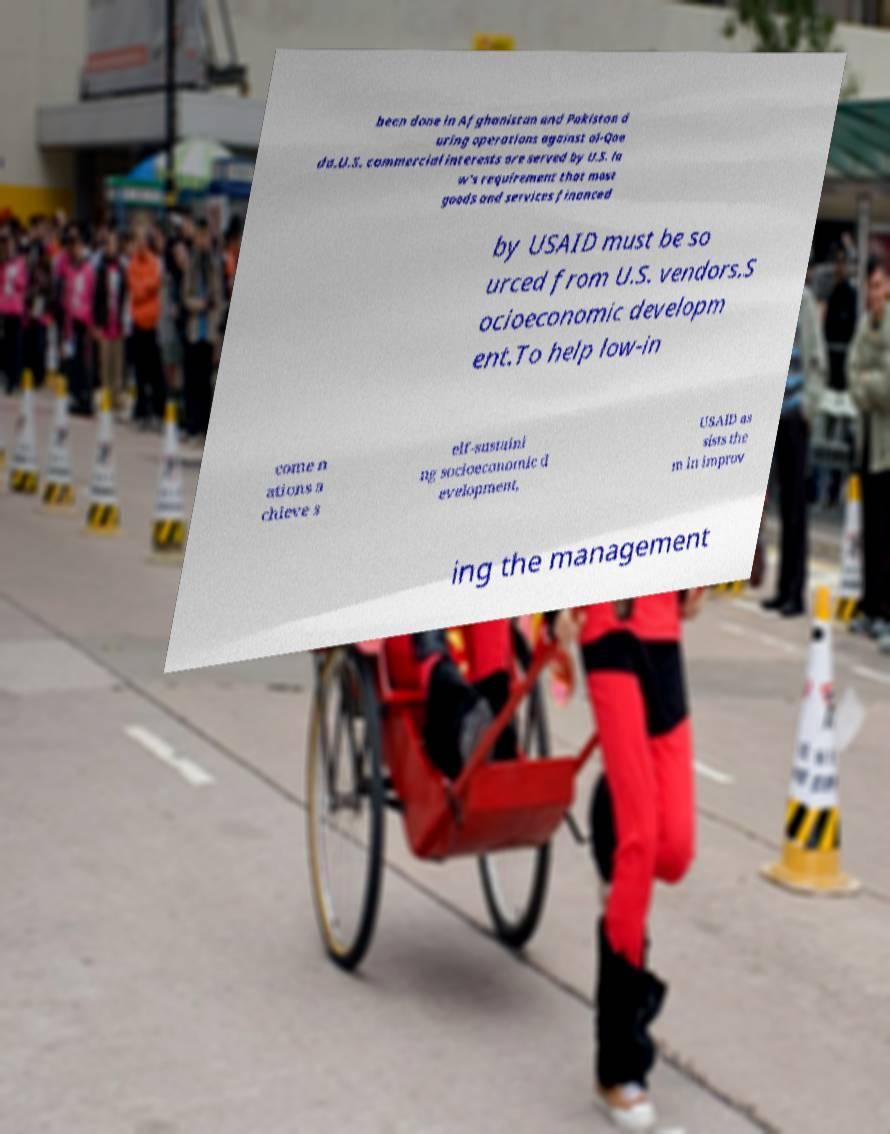There's text embedded in this image that I need extracted. Can you transcribe it verbatim? been done in Afghanistan and Pakistan d uring operations against al-Qae da.U.S. commercial interests are served by U.S. la w's requirement that most goods and services financed by USAID must be so urced from U.S. vendors.S ocioeconomic developm ent.To help low-in come n ations a chieve s elf-sustaini ng socioeconomic d evelopment, USAID as sists the m in improv ing the management 